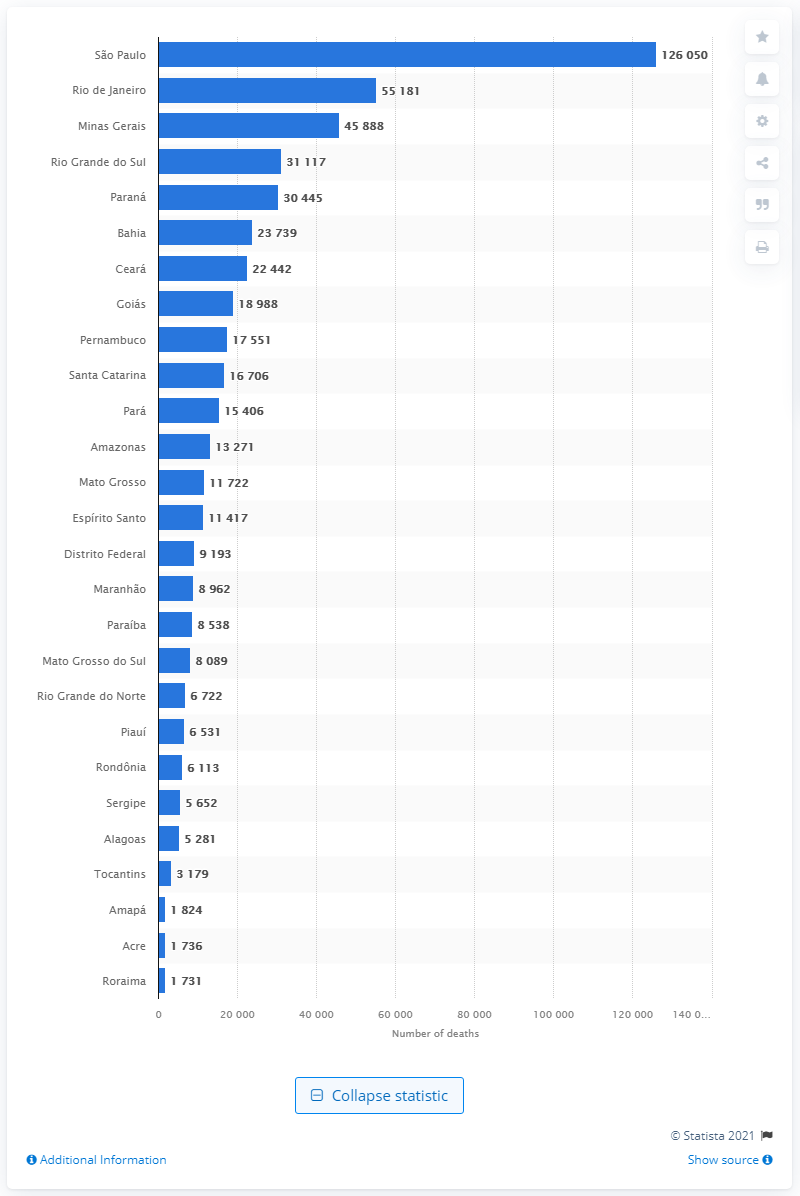Mention a couple of crucial points in this snapshot. As of June 27, 2021, there have been 126,050 deaths in São Paulo due to COVID-19. There were 55,181 deaths in Rio de Janeiro due to COVID-19. 